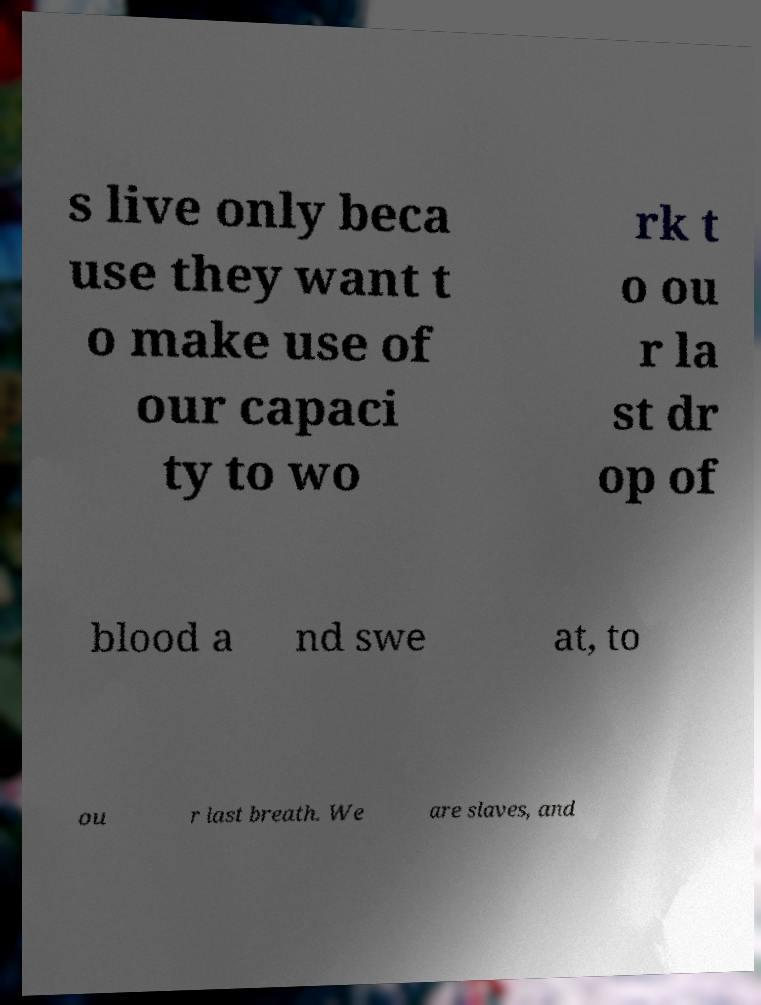Could you extract and type out the text from this image? s live only beca use they want t o make use of our capaci ty to wo rk t o ou r la st dr op of blood a nd swe at, to ou r last breath. We are slaves, and 